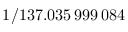<formula> <loc_0><loc_0><loc_500><loc_500>1 / 1 3 7 . 0 3 5 \, 9 9 9 \, 0 8 4</formula> 